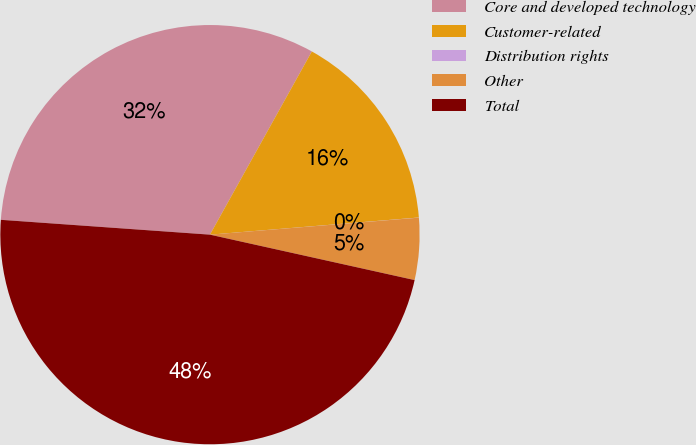<chart> <loc_0><loc_0><loc_500><loc_500><pie_chart><fcel>Core and developed technology<fcel>Customer-related<fcel>Distribution rights<fcel>Other<fcel>Total<nl><fcel>31.95%<fcel>15.62%<fcel>0.01%<fcel>4.77%<fcel>47.65%<nl></chart> 